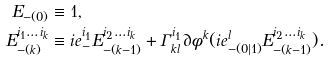Convert formula to latex. <formula><loc_0><loc_0><loc_500><loc_500>E _ { - ( 0 ) } & \equiv 1 , \\ E _ { - ( k ) } ^ { i _ { 1 } \dots i _ { k } } & \equiv i e _ { - } ^ { i _ { 1 } } E _ { - ( k - 1 ) } ^ { i _ { 2 } \dots i _ { k } } + \Gamma _ { k l } ^ { i _ { 1 } } \partial \phi ^ { k } ( i e ^ { l } _ { - ( 0 | 1 ) } E _ { - ( k - 1 ) } ^ { i _ { 2 } \dots i _ { k } } ) .</formula> 